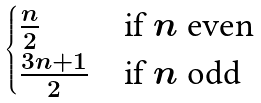<formula> <loc_0><loc_0><loc_500><loc_500>\begin{cases} \frac { n } { 2 } & \text {if $n$ even} \\ \frac { 3 n + 1 } { 2 } & \text {if $n$ odd} \end{cases}</formula> 